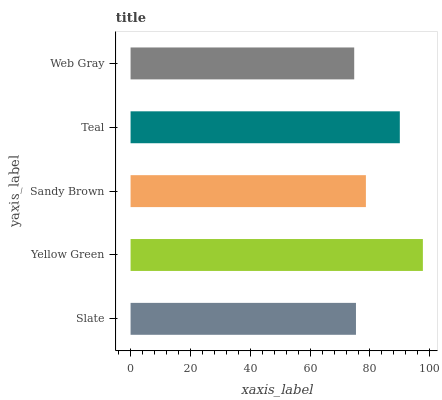Is Web Gray the minimum?
Answer yes or no. Yes. Is Yellow Green the maximum?
Answer yes or no. Yes. Is Sandy Brown the minimum?
Answer yes or no. No. Is Sandy Brown the maximum?
Answer yes or no. No. Is Yellow Green greater than Sandy Brown?
Answer yes or no. Yes. Is Sandy Brown less than Yellow Green?
Answer yes or no. Yes. Is Sandy Brown greater than Yellow Green?
Answer yes or no. No. Is Yellow Green less than Sandy Brown?
Answer yes or no. No. Is Sandy Brown the high median?
Answer yes or no. Yes. Is Sandy Brown the low median?
Answer yes or no. Yes. Is Slate the high median?
Answer yes or no. No. Is Slate the low median?
Answer yes or no. No. 